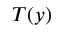<formula> <loc_0><loc_0><loc_500><loc_500>T ( y )</formula> 